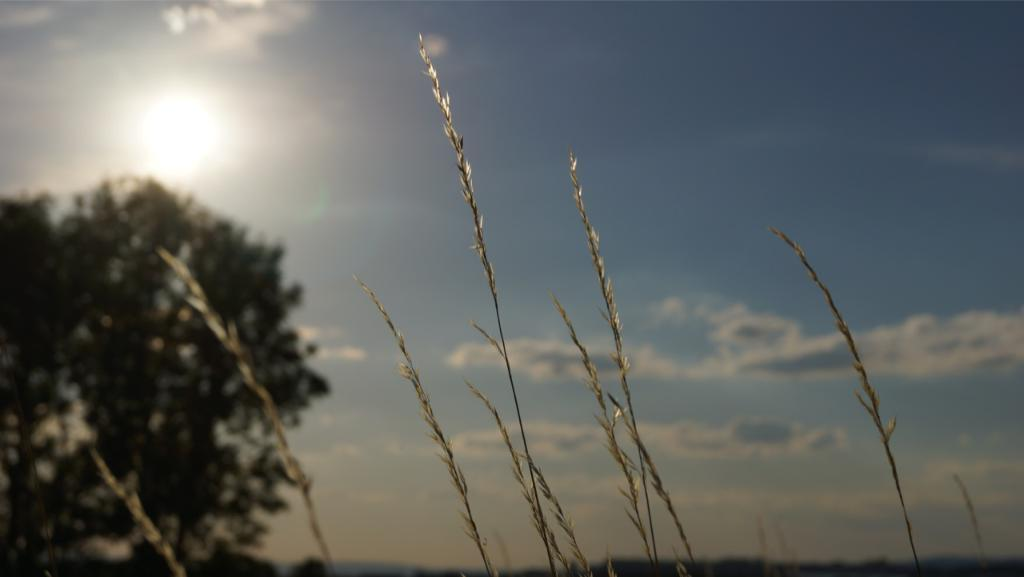What type of vegetation is present in the image? There is grass in the image. What other natural element can be seen in the image? There is a tree in the image. What is visible in the sky in the background of the image? The sun is visible in the sky in the background of the image. Can you describe the haircut of the person holding the wrench in the image? There is no person holding a wrench in the image, as it only features grass, a tree, and the sun in the sky. 